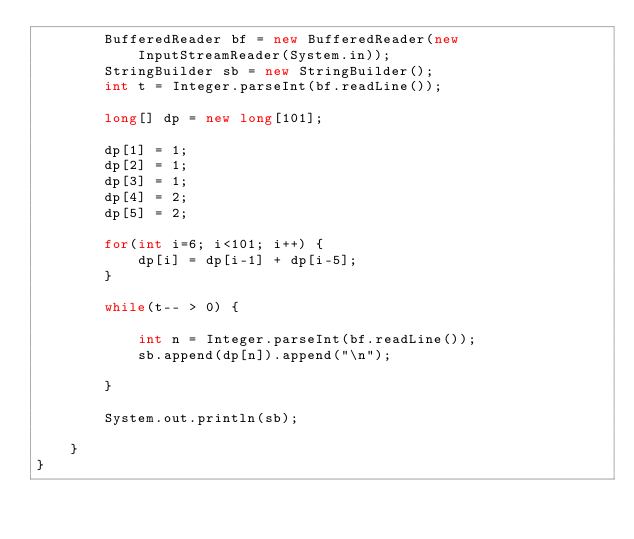Convert code to text. <code><loc_0><loc_0><loc_500><loc_500><_Java_>        BufferedReader bf = new BufferedReader(new InputStreamReader(System.in));
        StringBuilder sb = new StringBuilder();
        int t = Integer.parseInt(bf.readLine());

        long[] dp = new long[101];

        dp[1] = 1;
        dp[2] = 1;
        dp[3] = 1;
        dp[4] = 2;
        dp[5] = 2;

        for(int i=6; i<101; i++) {
            dp[i] = dp[i-1] + dp[i-5];
        }

        while(t-- > 0) {

            int n = Integer.parseInt(bf.readLine());
            sb.append(dp[n]).append("\n");

        }

        System.out.println(sb);

    }
}
</code> 